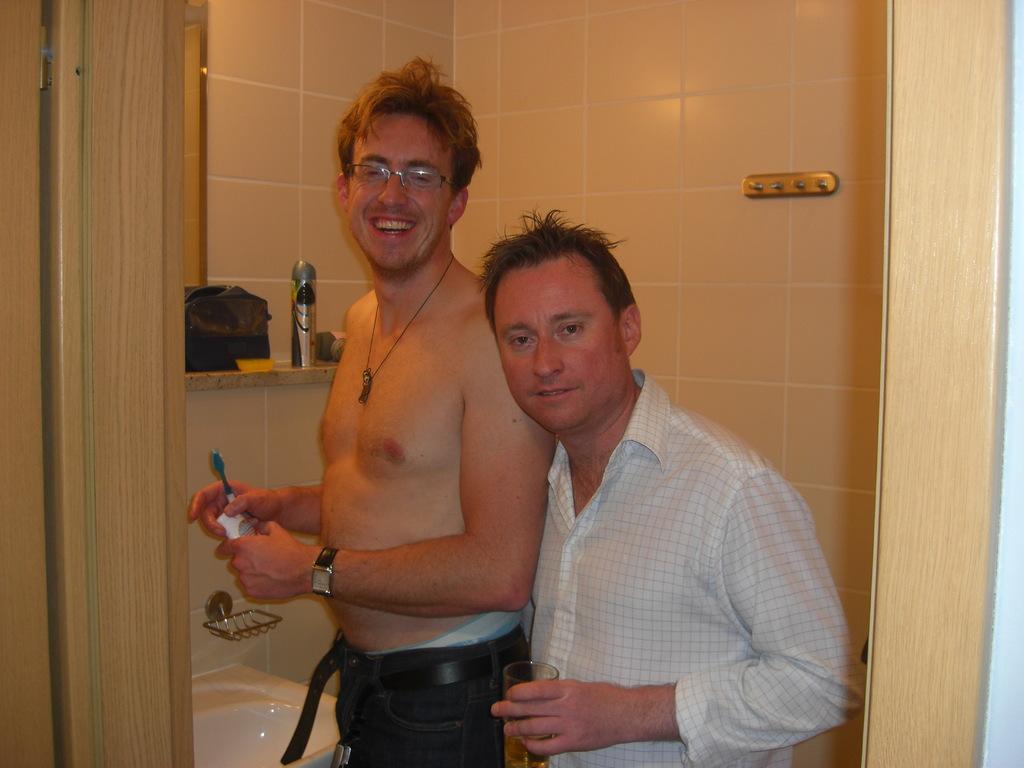Can you describe this image briefly? In this image there are two people standing with a smile on their face. Beside them there is a sink, one of them is holding a brush and a paste in his hand, above the sink there is a rack with some objects on top of it, behind them there is a wall and a hanger is hanging. On the left side of the image there is a door. 